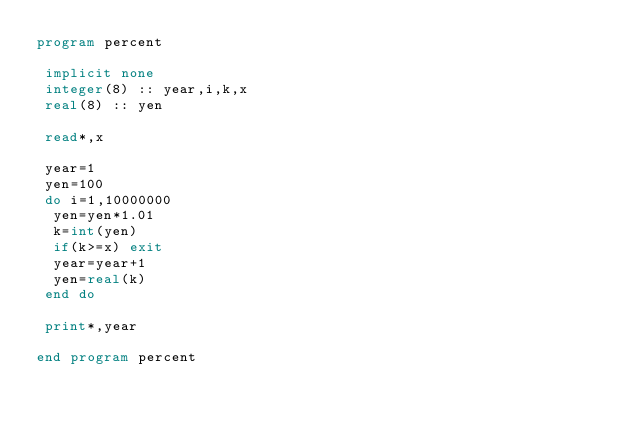<code> <loc_0><loc_0><loc_500><loc_500><_FORTRAN_>program percent

 implicit none
 integer(8) :: year,i,k,x
 real(8) :: yen

 read*,x
 
 year=1
 yen=100
 do i=1,10000000
  yen=yen*1.01
  k=int(yen)
  if(k>=x) exit
  year=year+1
  yen=real(k)
 end do

 print*,year

end program percent

 
  </code> 